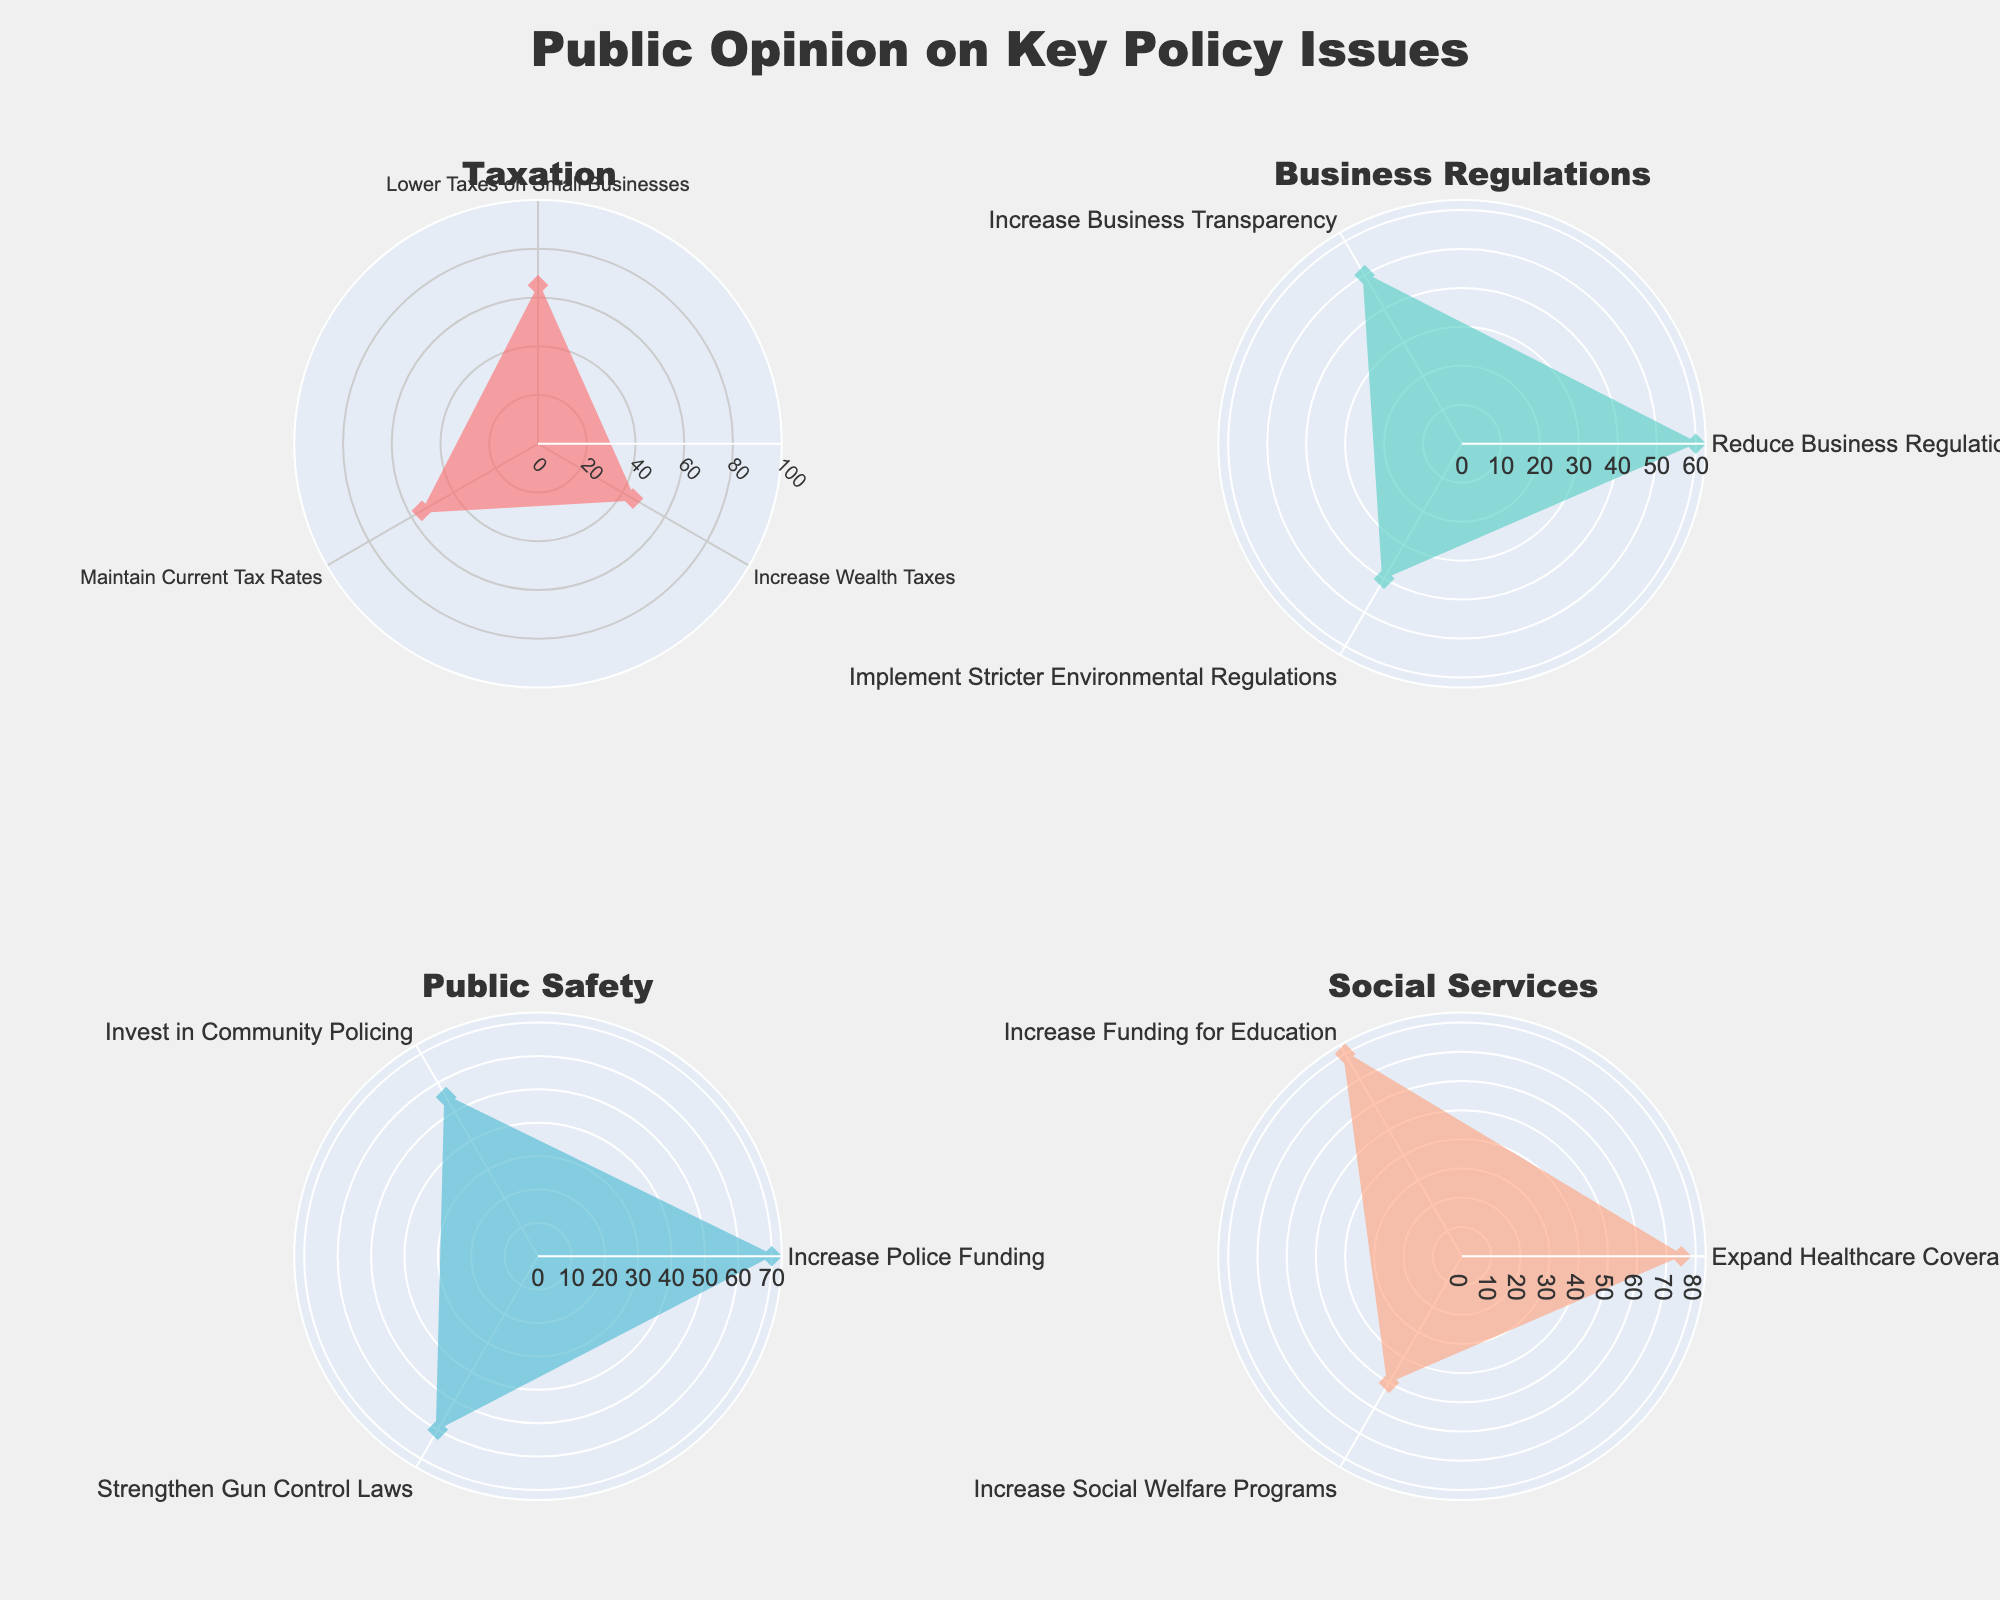What is the highest public opinion percentage for the Taxation policy? By examining the radar chart displaying the Taxation policy stances, identify the highest percentage value. The options are “Lower Taxes on Small Businesses” (65%), “Increase Wealth Taxes” (45%), and “Maintain Current Tax Rates” (55%).
Answer: 65% Which policy category has the highest public opinion percentage overall? Compare the highest values in each policy category's radar chart. Taxation has a peak of 65%, Business Regulations has 60%, Public Safety has 70%, and Social Services has 80%. The highest overall percentage is in Social Services.
Answer: Social Services What is the difference in public opinion between the highest stances in Public Safety and Business Regulations? Identify the highest percentage stances in Public Safety (70%) and Business Regulations (60%). Subtract the lower value from the higher one: 70% - 60% = 10%.
Answer: 10% Which stance has the lowest public opinion percentage in Social Services? Examine the radar chart for Social Services, identifying the lowest percentage values among the stances: “Expand Healthcare Coverage” (75%), “Increase Funding for Education” (80%), and “Increase Social Welfare Programs” (50%). The lowest is “Increase Social Welfare Programs” with 50%.
Answer: Increase Social Welfare Programs Rank the stances in Business Regulations from highest to lowest public opinion. Examine the radar chart for Business Regulations and order the stances by their percentage values: Reduce Business Regulations (60%), Increase Business Transparency (50%), and Implement Stricter Environmental Regulations (40%).
Answer: 1) Reduce Business Regulations, 2) Increase Business Transparency, 3) Implement Stricter Environmental Regulations What is the average public opinion percentage for the Taxation policy stances? Add the percentages for the stances under Taxation: 65%, 45%, and 55%, then divide by 3. (65 + 45 + 55) / 3 = 165 / 3 = 55%.
Answer: 55% Compare the public opinion of "Increase Police Funding" and "Strengthen Gun Control Laws" in Public Safety. Which has higher support? Examine the radar chart for Public Safety. “Increase Police Funding” has 70% and “Strengthen Gun Control Laws” has 60%. The former has higher support.
Answer: Increase Police Funding What is the total public opinion percentage for all stances in Social Services? Sum the percentages of all stances in Social Services: 75%, 80%, and 50%. 75 + 80 + 50 = 205%
Answer: 205% Which policy stance has exactly 50% public opinion? Check across all radar charts for a stance with exactly 50% support. “Increase Business Transparency” in Business Regulations and “Increase Social Welfare Programs” in Social Services both have 50%.
Answer: Increase Business Transparency, Increase Social Welfare Programs What percentage of the public supports "Implement Stricter Environmental Regulations"? Locate “Implement Stricter Environmental Regulations” in the Business Regulations radar chart to find its percentage: 40%.
Answer: 40% 